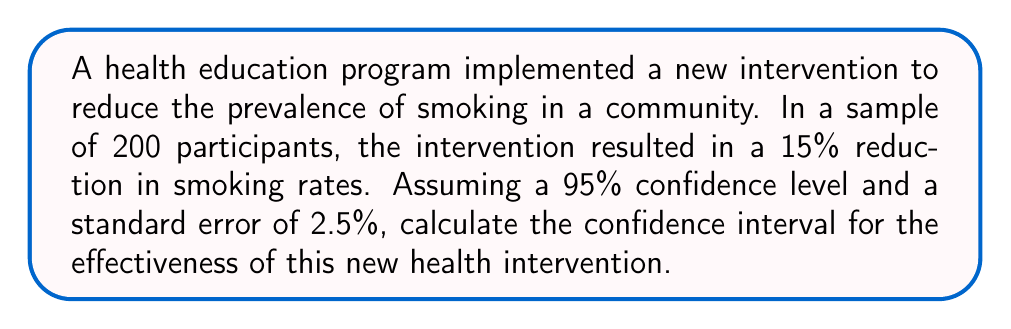Help me with this question. To calculate the confidence interval, we'll follow these steps:

1. Identify the given information:
   - Sample size (n) = 200
   - Point estimate (p̂) = 15% = 0.15
   - Confidence level = 95%
   - Standard error (SE) = 2.5% = 0.025

2. Determine the z-score for a 95% confidence level:
   The z-score for a 95% confidence interval is 1.96.

3. Calculate the margin of error:
   Margin of Error = z * SE
   $$ \text{Margin of Error} = 1.96 \times 0.025 = 0.049 $$

4. Calculate the confidence interval:
   CI = Point estimate ± Margin of Error
   $$ \text{CI} = 0.15 \pm 0.049 $$

5. Determine the lower and upper bounds of the confidence interval:
   Lower bound: $0.15 - 0.049 = 0.101$ or 10.1%
   Upper bound: $0.15 + 0.049 = 0.199$ or 19.9%

Therefore, we can say with 95% confidence that the true effectiveness of the new health intervention in reducing smoking rates lies between 10.1% and 19.9%.
Answer: (10.1%, 19.9%) 